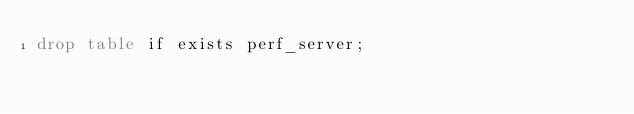Convert code to text. <code><loc_0><loc_0><loc_500><loc_500><_SQL_>drop table if exists perf_server;</code> 